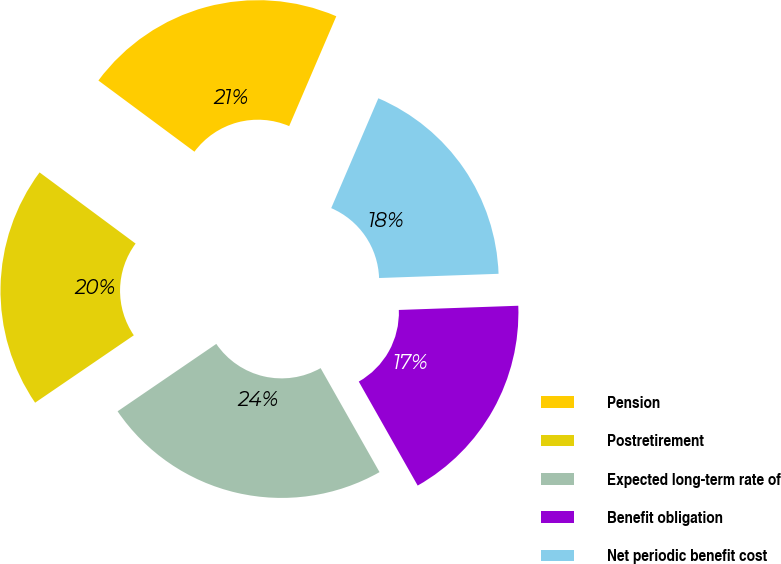Convert chart. <chart><loc_0><loc_0><loc_500><loc_500><pie_chart><fcel>Pension<fcel>Postretirement<fcel>Expected long-term rate of<fcel>Benefit obligation<fcel>Net periodic benefit cost<nl><fcel>21.3%<fcel>19.69%<fcel>23.67%<fcel>17.36%<fcel>17.99%<nl></chart> 